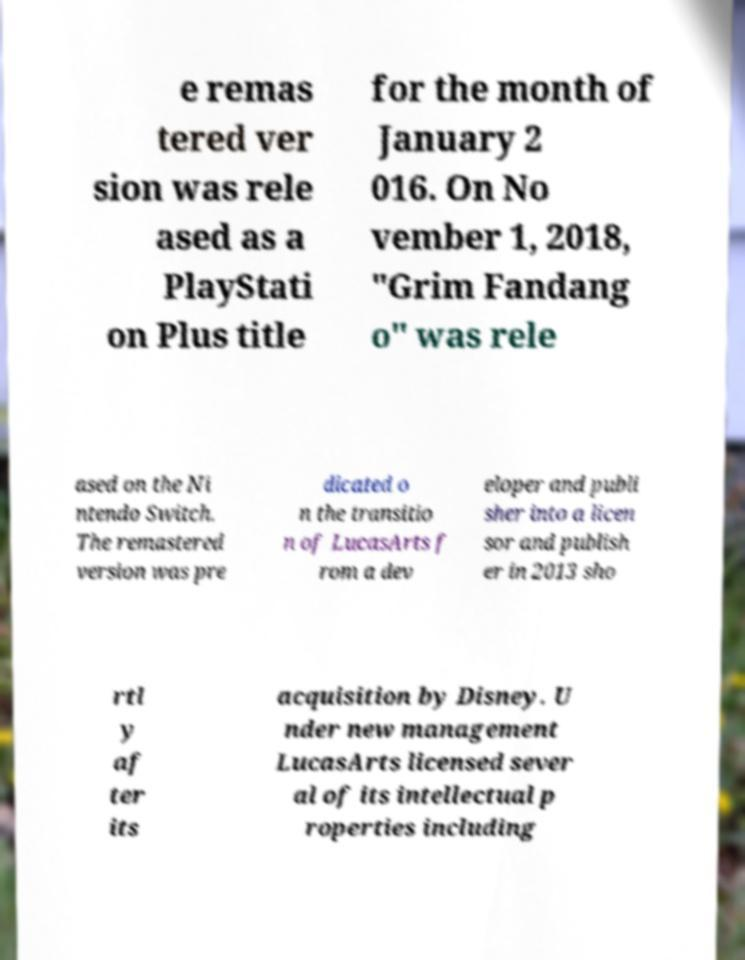Please read and relay the text visible in this image. What does it say? e remas tered ver sion was rele ased as a PlayStati on Plus title for the month of January 2 016. On No vember 1, 2018, "Grim Fandang o" was rele ased on the Ni ntendo Switch. The remastered version was pre dicated o n the transitio n of LucasArts f rom a dev eloper and publi sher into a licen sor and publish er in 2013 sho rtl y af ter its acquisition by Disney. U nder new management LucasArts licensed sever al of its intellectual p roperties including 